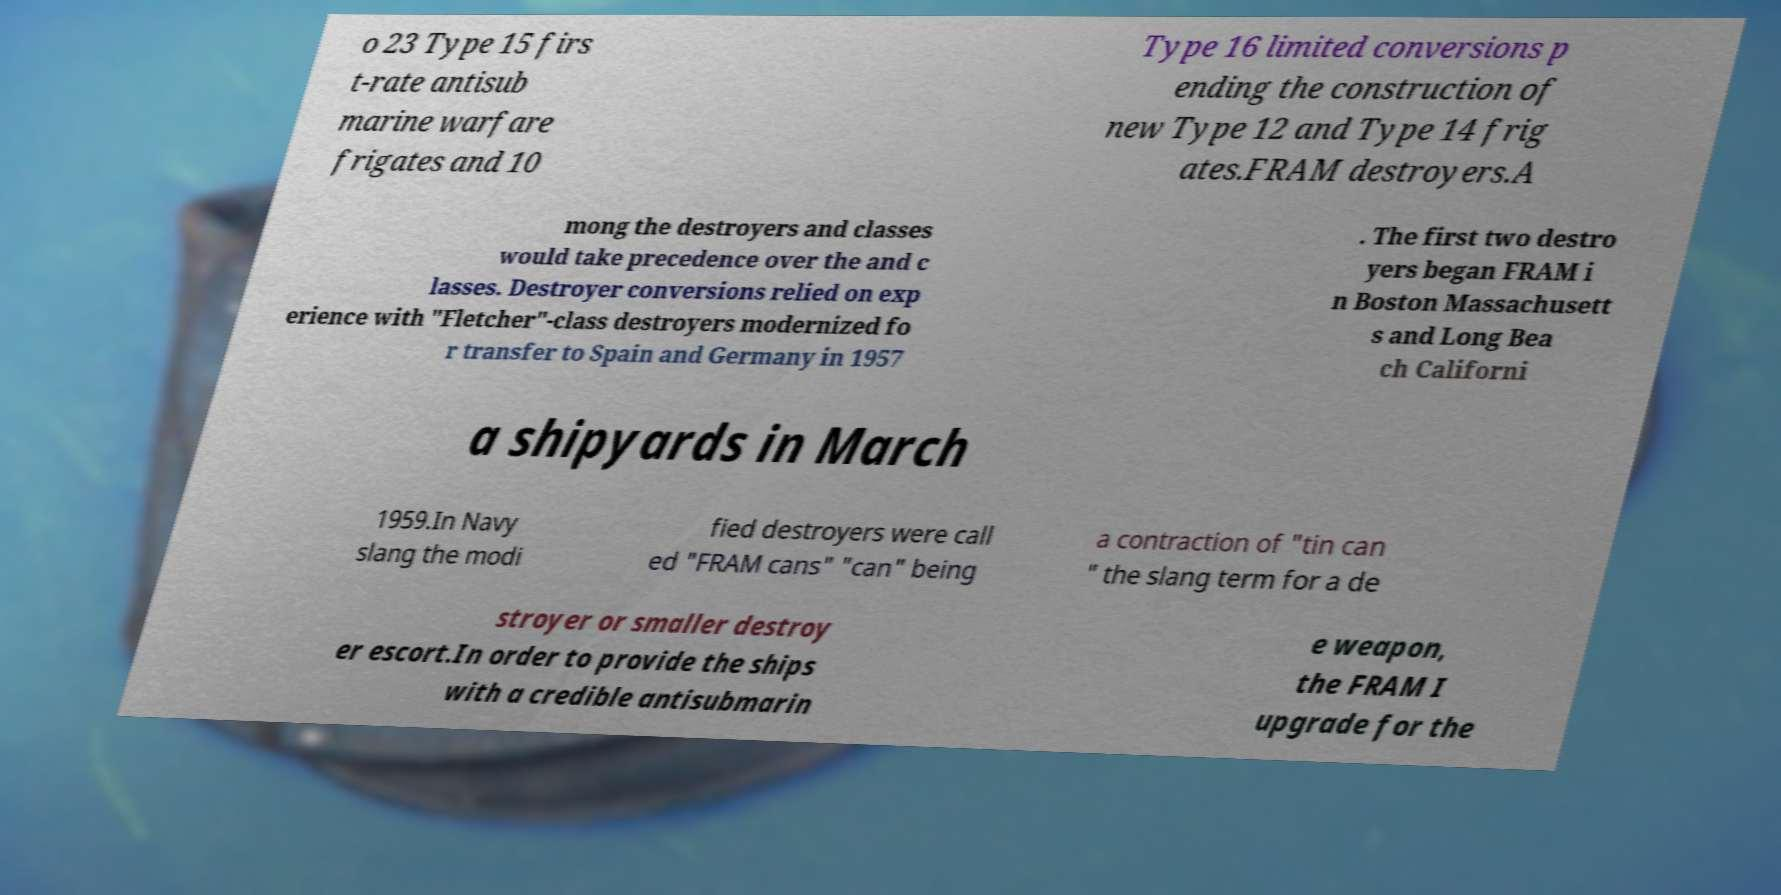There's text embedded in this image that I need extracted. Can you transcribe it verbatim? o 23 Type 15 firs t-rate antisub marine warfare frigates and 10 Type 16 limited conversions p ending the construction of new Type 12 and Type 14 frig ates.FRAM destroyers.A mong the destroyers and classes would take precedence over the and c lasses. Destroyer conversions relied on exp erience with "Fletcher"-class destroyers modernized fo r transfer to Spain and Germany in 1957 . The first two destro yers began FRAM i n Boston Massachusett s and Long Bea ch Californi a shipyards in March 1959.In Navy slang the modi fied destroyers were call ed "FRAM cans" "can" being a contraction of "tin can " the slang term for a de stroyer or smaller destroy er escort.In order to provide the ships with a credible antisubmarin e weapon, the FRAM I upgrade for the 